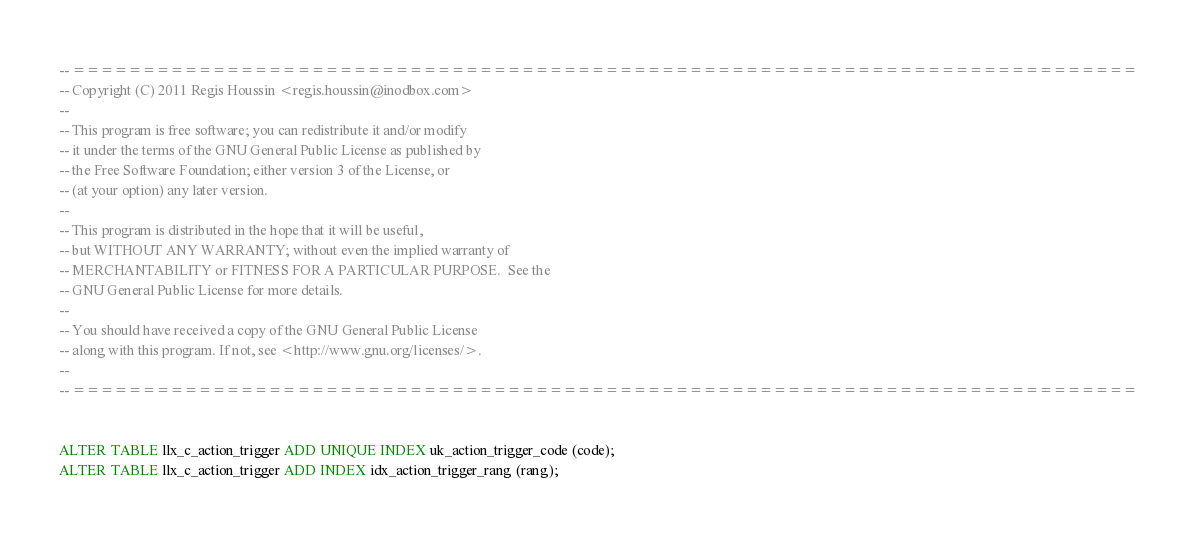Convert code to text. <code><loc_0><loc_0><loc_500><loc_500><_SQL_>-- ============================================================================
-- Copyright (C) 2011 Regis Houssin	<regis.houssin@inodbox.com>
--
-- This program is free software; you can redistribute it and/or modify
-- it under the terms of the GNU General Public License as published by
-- the Free Software Foundation; either version 3 of the License, or
-- (at your option) any later version.
--
-- This program is distributed in the hope that it will be useful,
-- but WITHOUT ANY WARRANTY; without even the implied warranty of
-- MERCHANTABILITY or FITNESS FOR A PARTICULAR PURPOSE.  See the
-- GNU General Public License for more details.
--
-- You should have received a copy of the GNU General Public License
-- along with this program. If not, see <http://www.gnu.org/licenses/>.
--
-- ============================================================================


ALTER TABLE llx_c_action_trigger ADD UNIQUE INDEX uk_action_trigger_code (code);
ALTER TABLE llx_c_action_trigger ADD INDEX idx_action_trigger_rang (rang);
</code> 